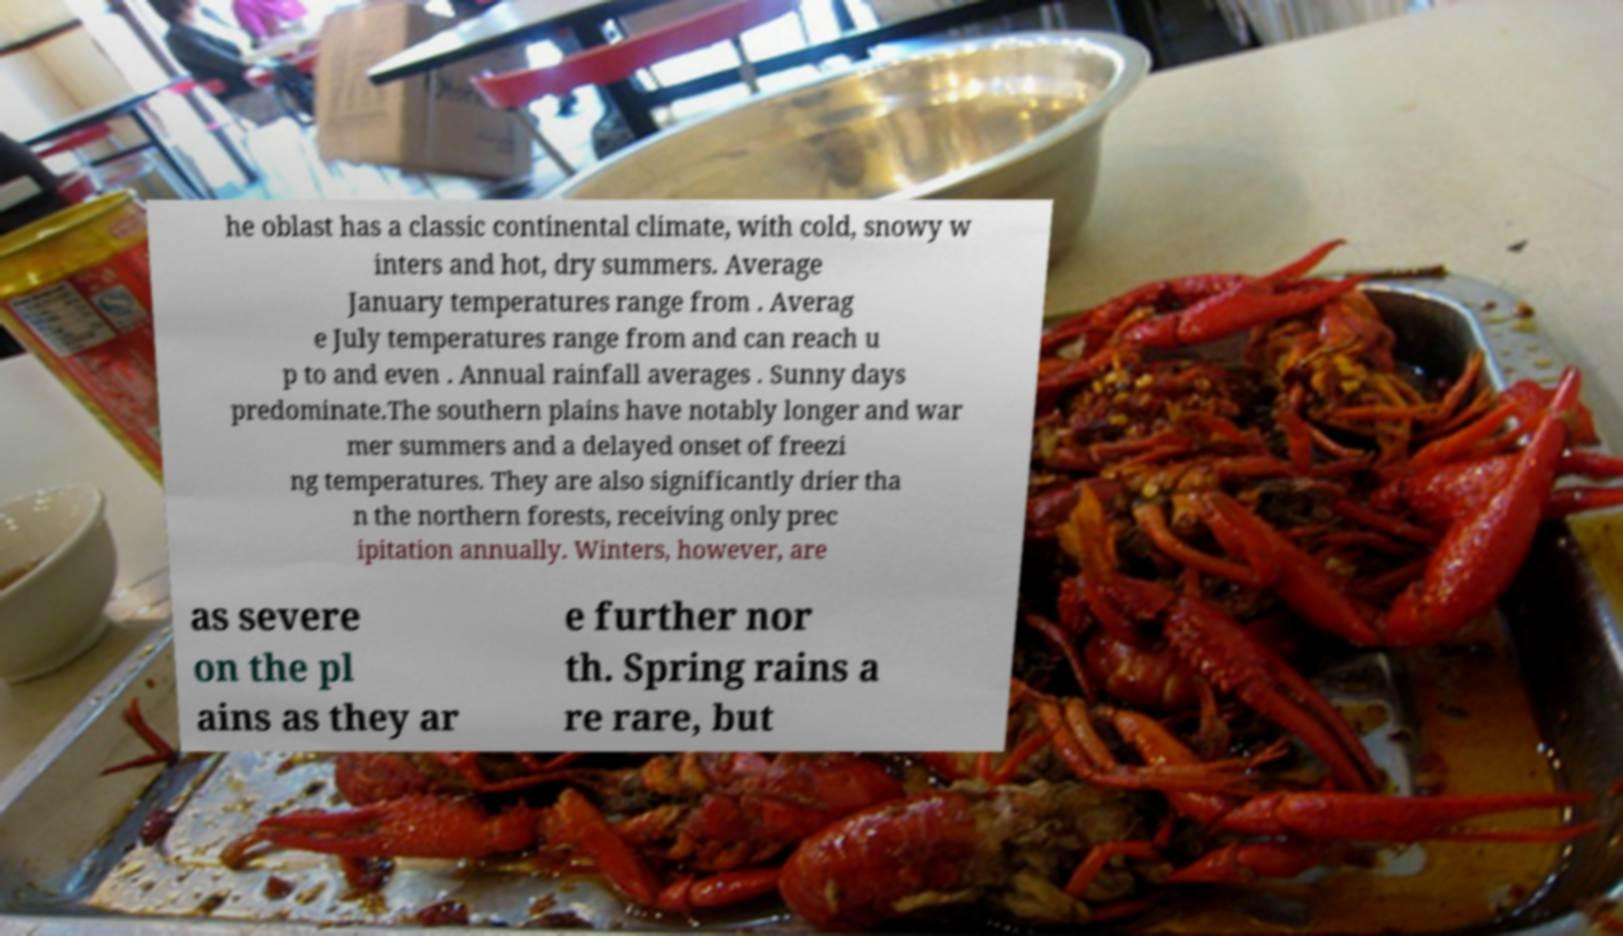Please read and relay the text visible in this image. What does it say? he oblast has a classic continental climate, with cold, snowy w inters and hot, dry summers. Average January temperatures range from . Averag e July temperatures range from and can reach u p to and even . Annual rainfall averages . Sunny days predominate.The southern plains have notably longer and war mer summers and a delayed onset of freezi ng temperatures. They are also significantly drier tha n the northern forests, receiving only prec ipitation annually. Winters, however, are as severe on the pl ains as they ar e further nor th. Spring rains a re rare, but 